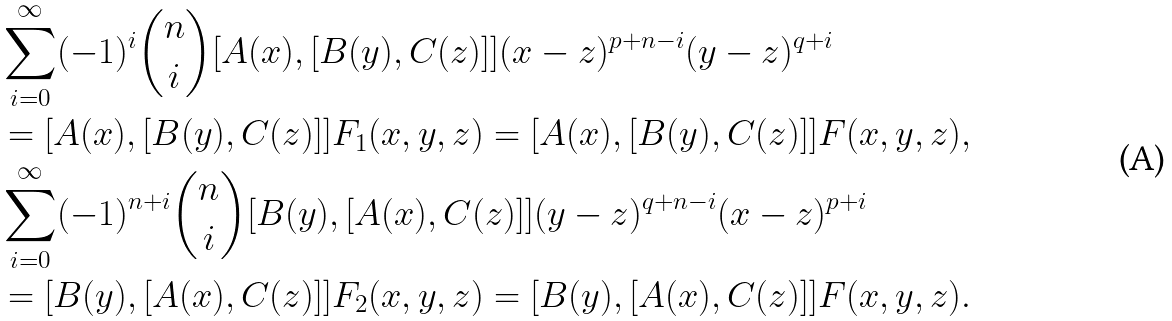<formula> <loc_0><loc_0><loc_500><loc_500>& \sum _ { i = 0 } ^ { \infty } ( - 1 ) ^ { i } \binom { n } { i } [ A ( x ) , [ B ( y ) , C ( z ) ] ] ( x - z ) ^ { p + n - i } ( y - z ) ^ { q + i } \\ & = [ A ( x ) , [ B ( y ) , C ( z ) ] ] F _ { 1 } ( x , y , z ) = [ A ( x ) , [ B ( y ) , C ( z ) ] ] F ( x , y , z ) , \\ & \sum _ { i = 0 } ^ { \infty } ( - 1 ) ^ { n + i } \binom { n } { i } [ B ( y ) , [ A ( x ) , C ( z ) ] ] ( y - z ) ^ { q + n - i } ( x - z ) ^ { p + i } \\ & = [ B ( y ) , [ A ( x ) , C ( z ) ] ] F _ { 2 } ( x , y , z ) = [ B ( y ) , [ A ( x ) , C ( z ) ] ] F ( x , y , z ) .</formula> 